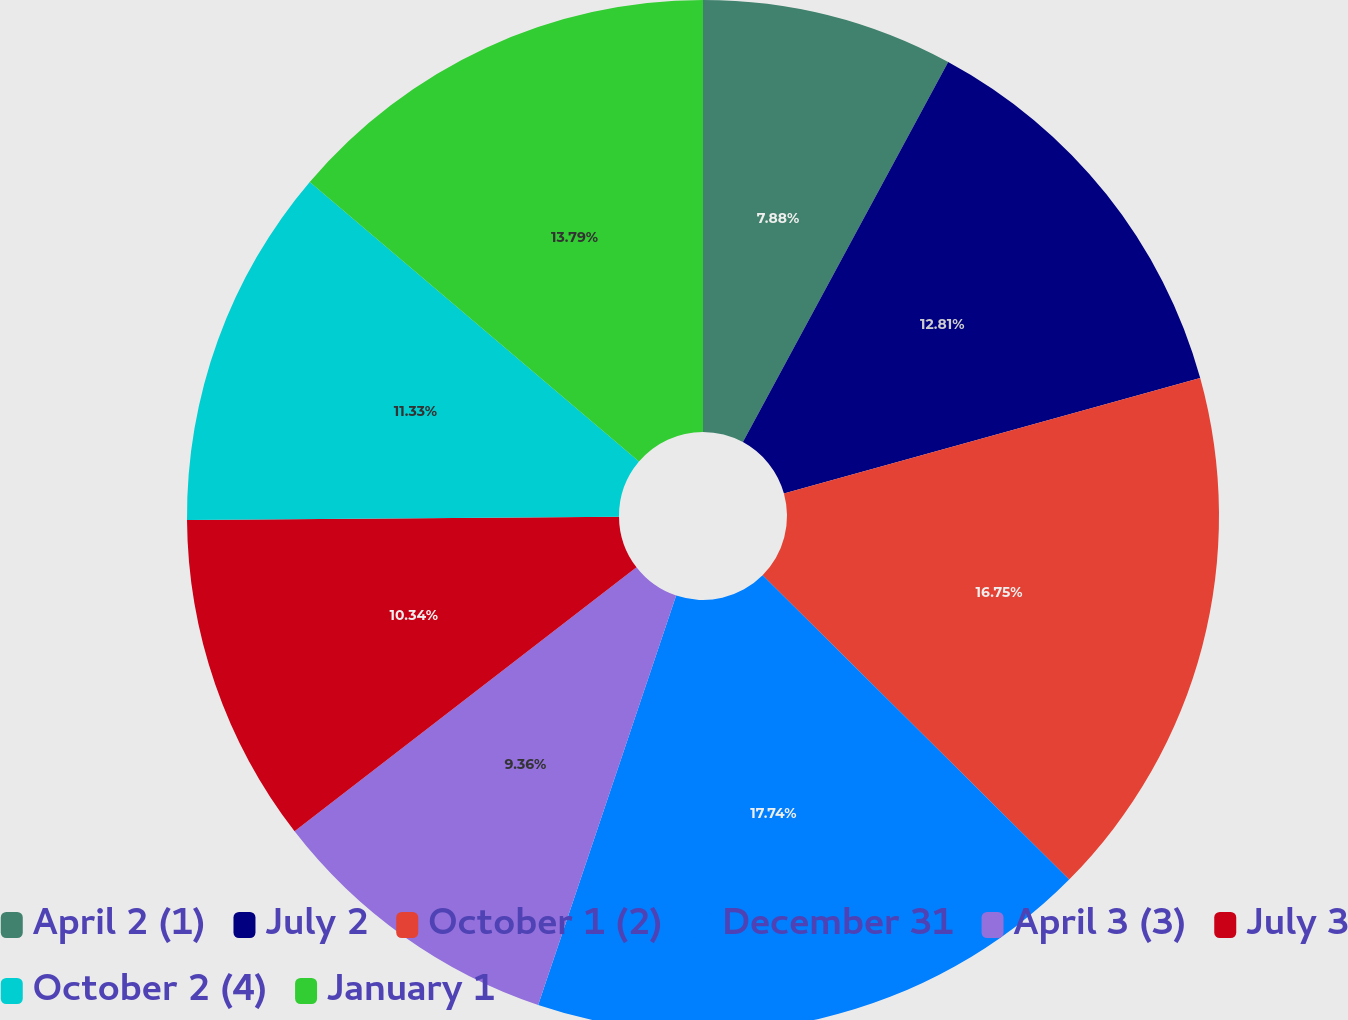<chart> <loc_0><loc_0><loc_500><loc_500><pie_chart><fcel>April 2 (1)<fcel>July 2<fcel>October 1 (2)<fcel>December 31<fcel>April 3 (3)<fcel>July 3<fcel>October 2 (4)<fcel>January 1<nl><fcel>7.88%<fcel>12.81%<fcel>16.75%<fcel>17.73%<fcel>9.36%<fcel>10.34%<fcel>11.33%<fcel>13.79%<nl></chart> 